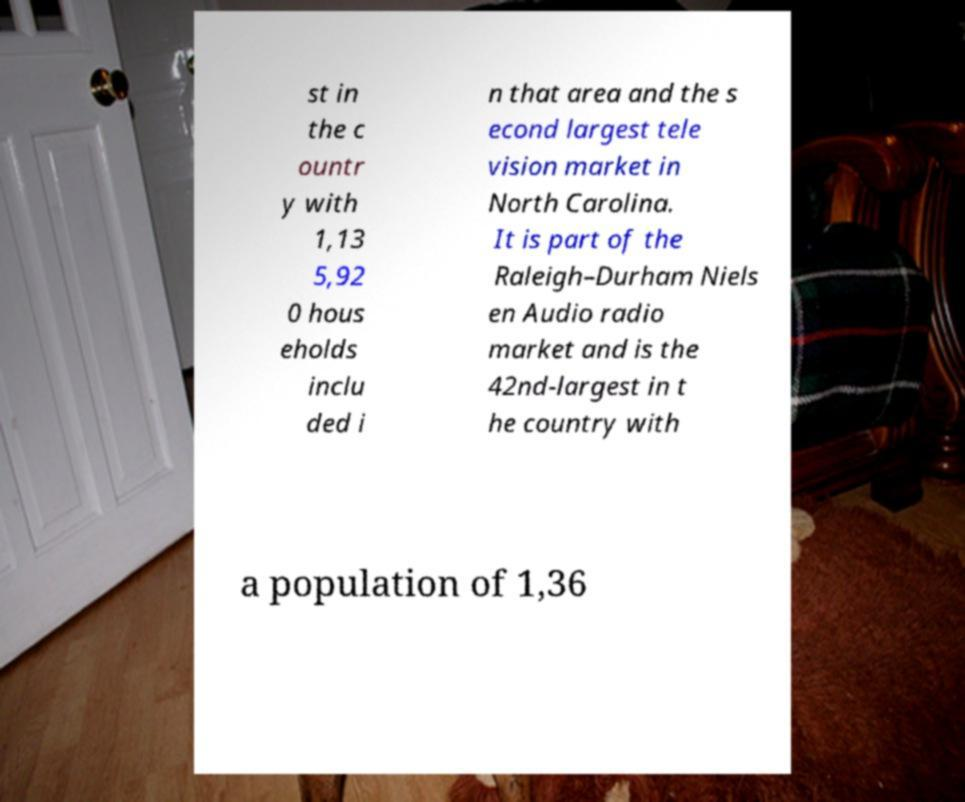Can you accurately transcribe the text from the provided image for me? st in the c ountr y with 1,13 5,92 0 hous eholds inclu ded i n that area and the s econd largest tele vision market in North Carolina. It is part of the Raleigh–Durham Niels en Audio radio market and is the 42nd-largest in t he country with a population of 1,36 